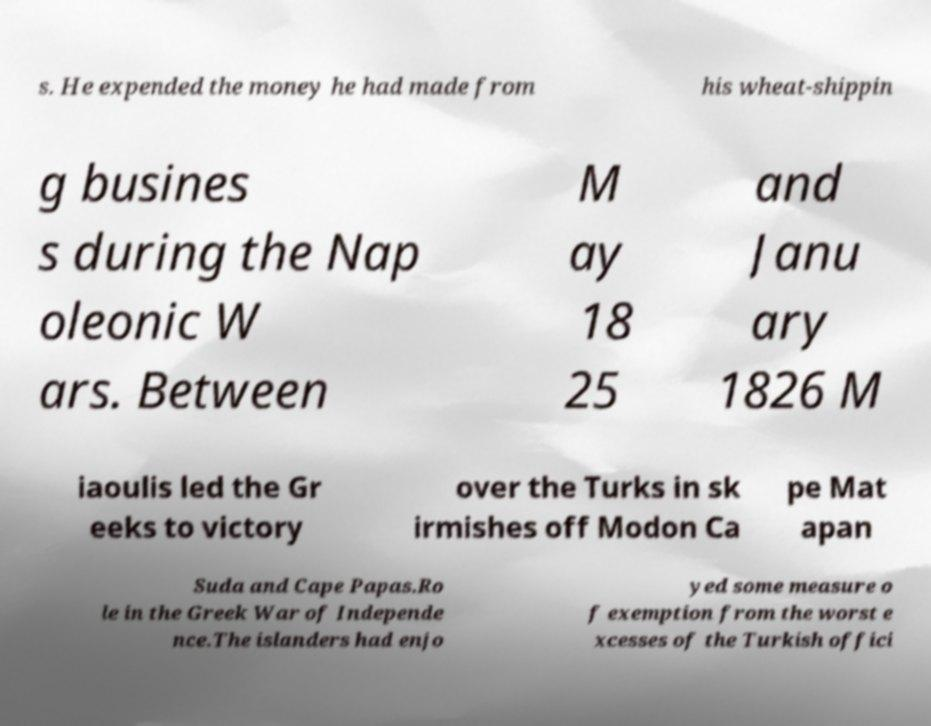What messages or text are displayed in this image? I need them in a readable, typed format. s. He expended the money he had made from his wheat-shippin g busines s during the Nap oleonic W ars. Between M ay 18 25 and Janu ary 1826 M iaoulis led the Gr eeks to victory over the Turks in sk irmishes off Modon Ca pe Mat apan Suda and Cape Papas.Ro le in the Greek War of Independe nce.The islanders had enjo yed some measure o f exemption from the worst e xcesses of the Turkish offici 